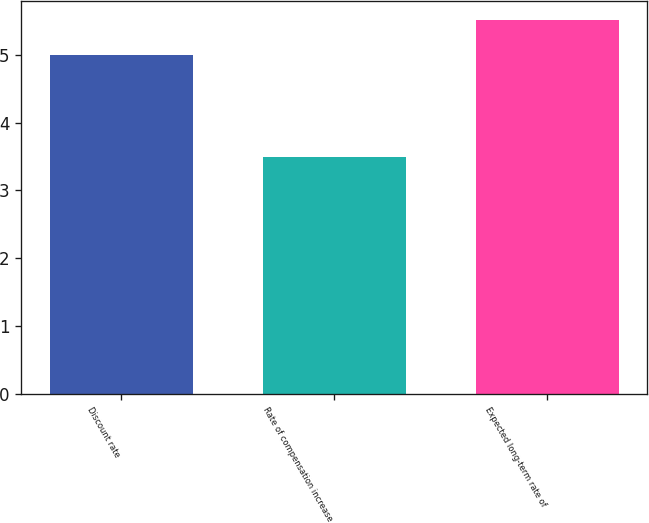<chart> <loc_0><loc_0><loc_500><loc_500><bar_chart><fcel>Discount rate<fcel>Rate of compensation increase<fcel>Expected long-term rate of<nl><fcel>5<fcel>3.5<fcel>5.52<nl></chart> 